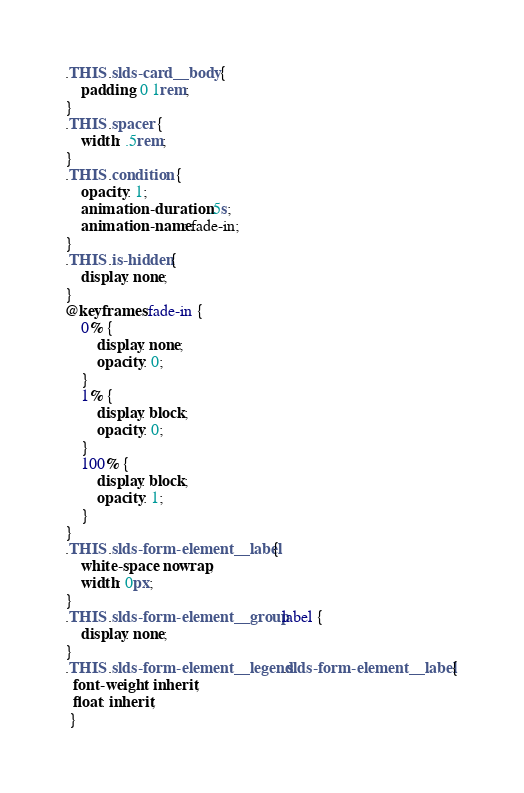Convert code to text. <code><loc_0><loc_0><loc_500><loc_500><_CSS_>.THIS .slds-card__body {
    padding: 0 1rem;
}
.THIS .spacer {
    width: .5rem;
}
.THIS .condition {
    opacity: 1;
    animation-duration: .5s;
    animation-name: fade-in;
}
.THIS .is-hidden{
    display: none;
}
@keyframes fade-in {
    0% {
        display: none;
        opacity: 0;
    }
    1% {
        display: block;
        opacity: 0;
    }
    100% {
        display: block;
        opacity: 1;
    }
}
.THIS .slds-form-element__label{
    white-space: nowrap;
    width: 0px;
}
.THIS .slds-form-element__group label {
    display: none;
}
.THIS .slds-form-element__legend.slds-form-element__label {
  font-weight: inherit;
  float: inherit;
 }</code> 